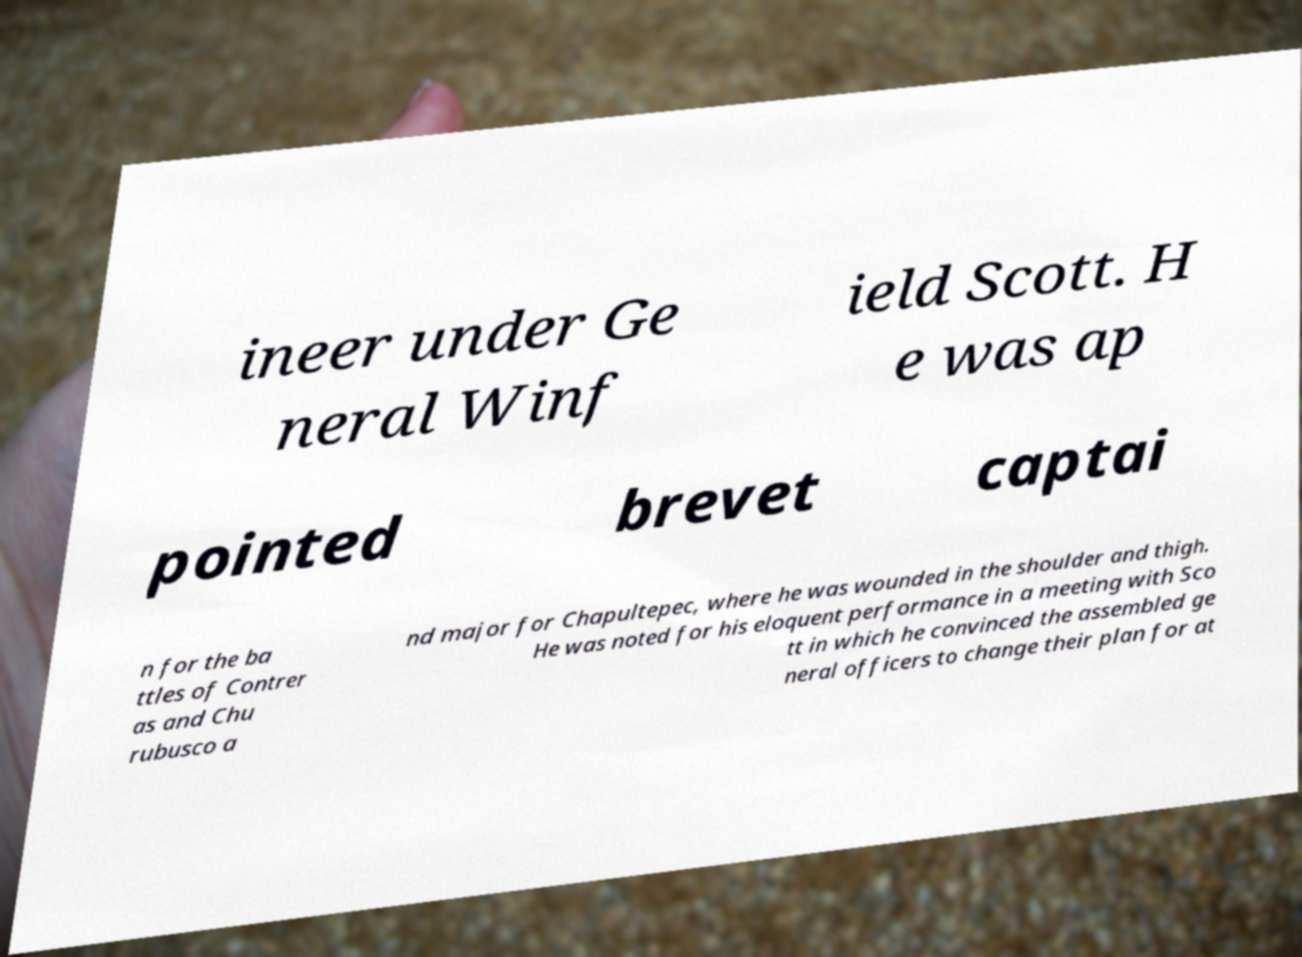I need the written content from this picture converted into text. Can you do that? ineer under Ge neral Winf ield Scott. H e was ap pointed brevet captai n for the ba ttles of Contrer as and Chu rubusco a nd major for Chapultepec, where he was wounded in the shoulder and thigh. He was noted for his eloquent performance in a meeting with Sco tt in which he convinced the assembled ge neral officers to change their plan for at 